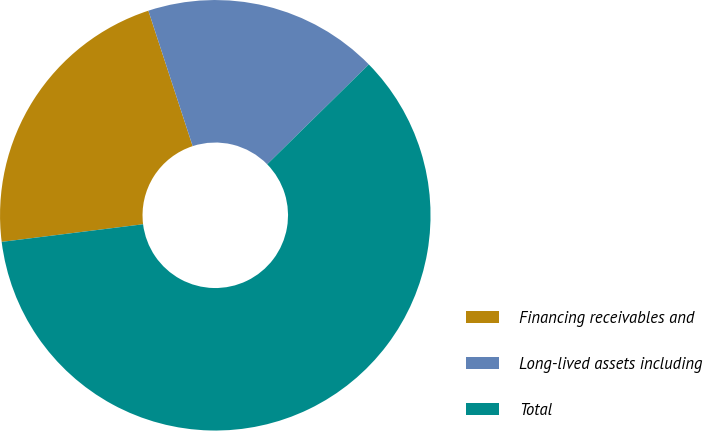<chart> <loc_0><loc_0><loc_500><loc_500><pie_chart><fcel>Financing receivables and<fcel>Long-lived assets including<fcel>Total<nl><fcel>21.94%<fcel>17.67%<fcel>60.38%<nl></chart> 